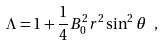<formula> <loc_0><loc_0><loc_500><loc_500>\Lambda = 1 + \frac { 1 } { 4 } B _ { 0 } ^ { 2 } r ^ { 2 } \sin ^ { 2 } \theta \ ,</formula> 